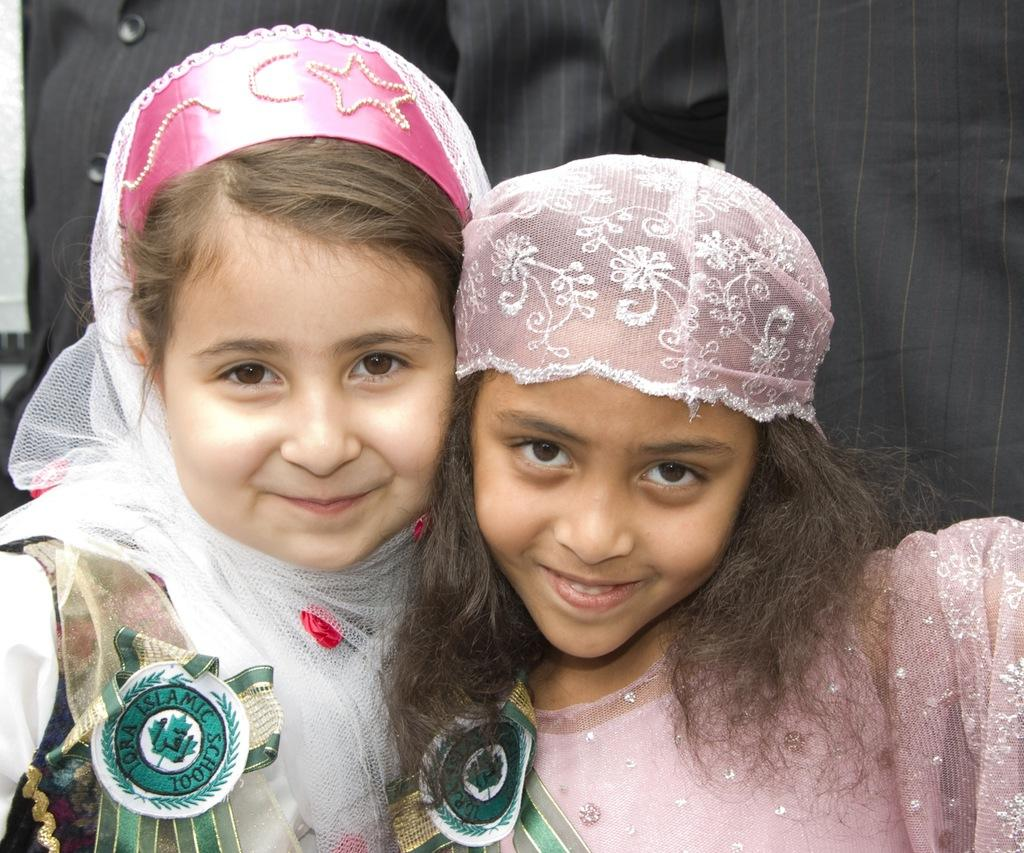How many people are in the image? There are two girls in the image. What is the facial expression of the girls? The girls have smiling faces. Can you describe the person in the background of the image? Unfortunately, the facts provided do not give any information about the person in the background. What color is the crayon that the girls are using in the image? There is no crayon present in the image. What type of punishment is being given to the girls in the image? There is no indication of punishment in the image; the girls have smiling faces. 